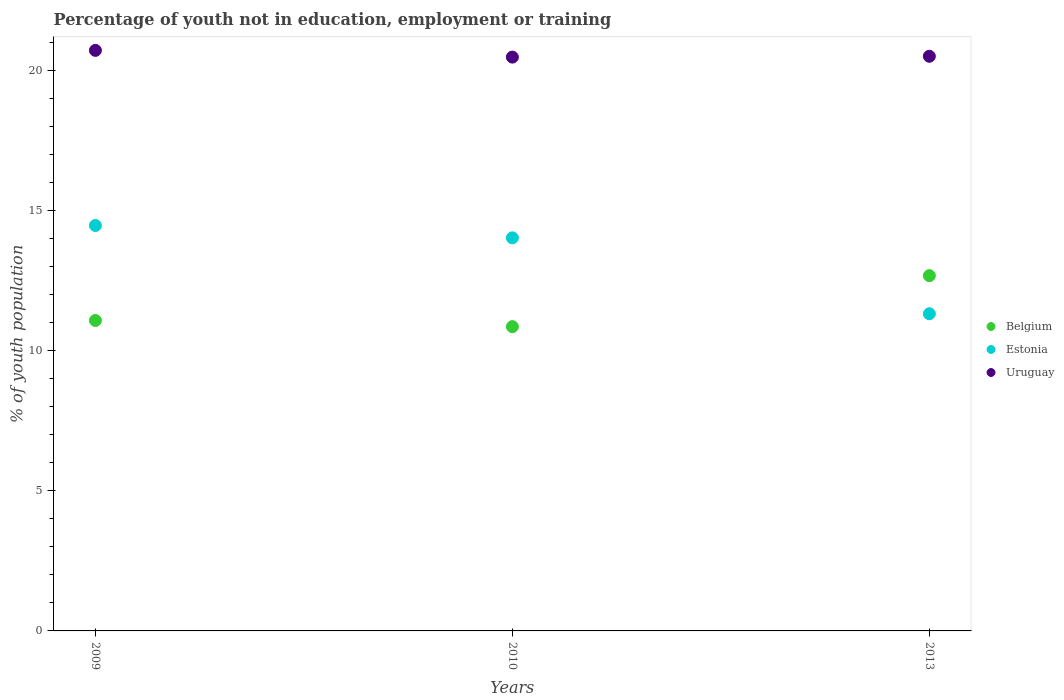How many different coloured dotlines are there?
Make the answer very short. 3. What is the percentage of unemployed youth population in in Uruguay in 2009?
Your response must be concise. 20.72. Across all years, what is the maximum percentage of unemployed youth population in in Belgium?
Make the answer very short. 12.68. Across all years, what is the minimum percentage of unemployed youth population in in Uruguay?
Your response must be concise. 20.48. What is the total percentage of unemployed youth population in in Estonia in the graph?
Provide a short and direct response. 39.82. What is the difference between the percentage of unemployed youth population in in Estonia in 2009 and that in 2013?
Ensure brevity in your answer.  3.15. What is the difference between the percentage of unemployed youth population in in Uruguay in 2013 and the percentage of unemployed youth population in in Belgium in 2010?
Your response must be concise. 9.65. What is the average percentage of unemployed youth population in in Belgium per year?
Give a very brief answer. 11.54. In the year 2010, what is the difference between the percentage of unemployed youth population in in Estonia and percentage of unemployed youth population in in Belgium?
Give a very brief answer. 3.17. In how many years, is the percentage of unemployed youth population in in Belgium greater than 19 %?
Your answer should be compact. 0. What is the ratio of the percentage of unemployed youth population in in Estonia in 2009 to that in 2013?
Your answer should be very brief. 1.28. Is the percentage of unemployed youth population in in Belgium in 2010 less than that in 2013?
Ensure brevity in your answer.  Yes. What is the difference between the highest and the second highest percentage of unemployed youth population in in Belgium?
Give a very brief answer. 1.6. What is the difference between the highest and the lowest percentage of unemployed youth population in in Uruguay?
Offer a very short reply. 0.24. In how many years, is the percentage of unemployed youth population in in Belgium greater than the average percentage of unemployed youth population in in Belgium taken over all years?
Provide a succinct answer. 1. Is it the case that in every year, the sum of the percentage of unemployed youth population in in Belgium and percentage of unemployed youth population in in Uruguay  is greater than the percentage of unemployed youth population in in Estonia?
Make the answer very short. Yes. Does the percentage of unemployed youth population in in Belgium monotonically increase over the years?
Your response must be concise. No. How many years are there in the graph?
Provide a succinct answer. 3. Does the graph contain grids?
Offer a terse response. No. Where does the legend appear in the graph?
Ensure brevity in your answer.  Center right. What is the title of the graph?
Ensure brevity in your answer.  Percentage of youth not in education, employment or training. What is the label or title of the X-axis?
Offer a terse response. Years. What is the label or title of the Y-axis?
Provide a short and direct response. % of youth population. What is the % of youth population of Belgium in 2009?
Offer a terse response. 11.08. What is the % of youth population in Estonia in 2009?
Your response must be concise. 14.47. What is the % of youth population of Uruguay in 2009?
Provide a succinct answer. 20.72. What is the % of youth population of Belgium in 2010?
Give a very brief answer. 10.86. What is the % of youth population of Estonia in 2010?
Provide a short and direct response. 14.03. What is the % of youth population in Uruguay in 2010?
Make the answer very short. 20.48. What is the % of youth population of Belgium in 2013?
Make the answer very short. 12.68. What is the % of youth population of Estonia in 2013?
Ensure brevity in your answer.  11.32. What is the % of youth population in Uruguay in 2013?
Your response must be concise. 20.51. Across all years, what is the maximum % of youth population in Belgium?
Provide a short and direct response. 12.68. Across all years, what is the maximum % of youth population of Estonia?
Your answer should be compact. 14.47. Across all years, what is the maximum % of youth population of Uruguay?
Provide a succinct answer. 20.72. Across all years, what is the minimum % of youth population in Belgium?
Your response must be concise. 10.86. Across all years, what is the minimum % of youth population in Estonia?
Your answer should be compact. 11.32. Across all years, what is the minimum % of youth population in Uruguay?
Ensure brevity in your answer.  20.48. What is the total % of youth population in Belgium in the graph?
Provide a short and direct response. 34.62. What is the total % of youth population in Estonia in the graph?
Ensure brevity in your answer.  39.82. What is the total % of youth population of Uruguay in the graph?
Keep it short and to the point. 61.71. What is the difference between the % of youth population of Belgium in 2009 and that in 2010?
Your response must be concise. 0.22. What is the difference between the % of youth population of Estonia in 2009 and that in 2010?
Your answer should be very brief. 0.44. What is the difference between the % of youth population in Uruguay in 2009 and that in 2010?
Provide a short and direct response. 0.24. What is the difference between the % of youth population in Belgium in 2009 and that in 2013?
Make the answer very short. -1.6. What is the difference between the % of youth population of Estonia in 2009 and that in 2013?
Give a very brief answer. 3.15. What is the difference between the % of youth population of Uruguay in 2009 and that in 2013?
Offer a very short reply. 0.21. What is the difference between the % of youth population in Belgium in 2010 and that in 2013?
Your response must be concise. -1.82. What is the difference between the % of youth population of Estonia in 2010 and that in 2013?
Offer a very short reply. 2.71. What is the difference between the % of youth population of Uruguay in 2010 and that in 2013?
Your answer should be very brief. -0.03. What is the difference between the % of youth population in Belgium in 2009 and the % of youth population in Estonia in 2010?
Give a very brief answer. -2.95. What is the difference between the % of youth population in Estonia in 2009 and the % of youth population in Uruguay in 2010?
Your answer should be very brief. -6.01. What is the difference between the % of youth population in Belgium in 2009 and the % of youth population in Estonia in 2013?
Ensure brevity in your answer.  -0.24. What is the difference between the % of youth population in Belgium in 2009 and the % of youth population in Uruguay in 2013?
Make the answer very short. -9.43. What is the difference between the % of youth population of Estonia in 2009 and the % of youth population of Uruguay in 2013?
Provide a short and direct response. -6.04. What is the difference between the % of youth population in Belgium in 2010 and the % of youth population in Estonia in 2013?
Offer a terse response. -0.46. What is the difference between the % of youth population in Belgium in 2010 and the % of youth population in Uruguay in 2013?
Provide a short and direct response. -9.65. What is the difference between the % of youth population of Estonia in 2010 and the % of youth population of Uruguay in 2013?
Ensure brevity in your answer.  -6.48. What is the average % of youth population of Belgium per year?
Make the answer very short. 11.54. What is the average % of youth population in Estonia per year?
Provide a succinct answer. 13.27. What is the average % of youth population of Uruguay per year?
Your response must be concise. 20.57. In the year 2009, what is the difference between the % of youth population in Belgium and % of youth population in Estonia?
Offer a very short reply. -3.39. In the year 2009, what is the difference between the % of youth population in Belgium and % of youth population in Uruguay?
Offer a very short reply. -9.64. In the year 2009, what is the difference between the % of youth population of Estonia and % of youth population of Uruguay?
Give a very brief answer. -6.25. In the year 2010, what is the difference between the % of youth population in Belgium and % of youth population in Estonia?
Your answer should be compact. -3.17. In the year 2010, what is the difference between the % of youth population of Belgium and % of youth population of Uruguay?
Make the answer very short. -9.62. In the year 2010, what is the difference between the % of youth population of Estonia and % of youth population of Uruguay?
Offer a very short reply. -6.45. In the year 2013, what is the difference between the % of youth population of Belgium and % of youth population of Estonia?
Keep it short and to the point. 1.36. In the year 2013, what is the difference between the % of youth population of Belgium and % of youth population of Uruguay?
Offer a very short reply. -7.83. In the year 2013, what is the difference between the % of youth population in Estonia and % of youth population in Uruguay?
Your answer should be compact. -9.19. What is the ratio of the % of youth population in Belgium in 2009 to that in 2010?
Your answer should be very brief. 1.02. What is the ratio of the % of youth population in Estonia in 2009 to that in 2010?
Provide a short and direct response. 1.03. What is the ratio of the % of youth population of Uruguay in 2009 to that in 2010?
Your answer should be very brief. 1.01. What is the ratio of the % of youth population of Belgium in 2009 to that in 2013?
Give a very brief answer. 0.87. What is the ratio of the % of youth population in Estonia in 2009 to that in 2013?
Provide a short and direct response. 1.28. What is the ratio of the % of youth population in Uruguay in 2009 to that in 2013?
Your answer should be very brief. 1.01. What is the ratio of the % of youth population of Belgium in 2010 to that in 2013?
Keep it short and to the point. 0.86. What is the ratio of the % of youth population in Estonia in 2010 to that in 2013?
Provide a succinct answer. 1.24. What is the difference between the highest and the second highest % of youth population in Estonia?
Offer a terse response. 0.44. What is the difference between the highest and the second highest % of youth population in Uruguay?
Offer a very short reply. 0.21. What is the difference between the highest and the lowest % of youth population of Belgium?
Give a very brief answer. 1.82. What is the difference between the highest and the lowest % of youth population in Estonia?
Keep it short and to the point. 3.15. What is the difference between the highest and the lowest % of youth population of Uruguay?
Your response must be concise. 0.24. 